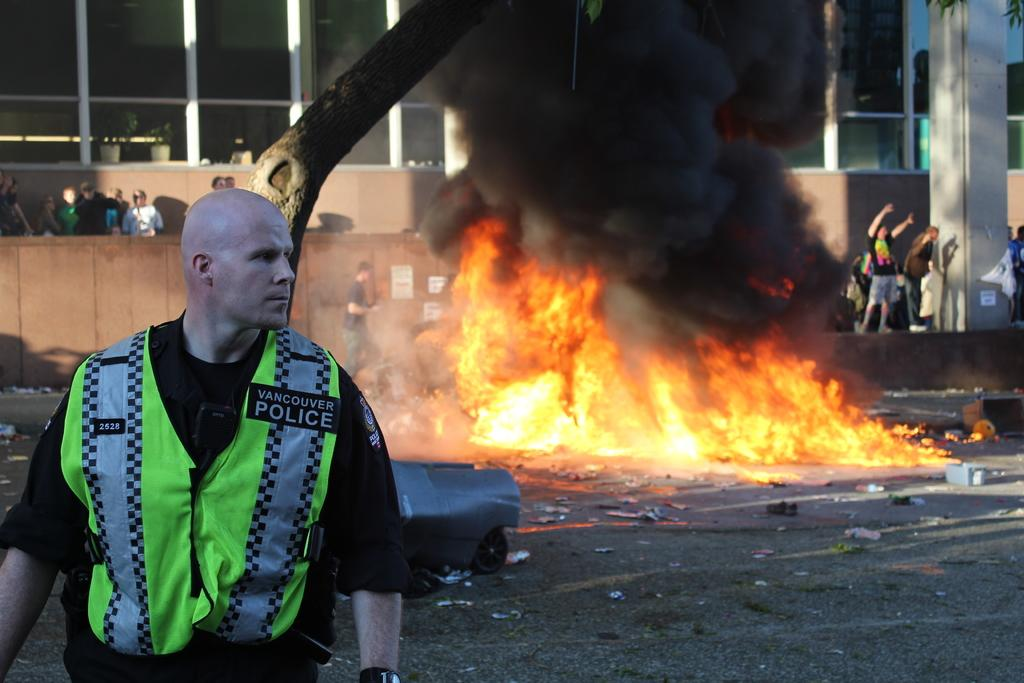Where is the person located in the image? The person is standing in the bottom left corner of the image. What is happening behind the person? There is fire behind the person. Are there any other people in the image? Yes, there are people standing behind the fire. What can be seen at the top of the image? There is a building visible at the top of the image. How many goldfish are swimming in the water near the person in the image? There are no goldfish present in the image. What is the size of the pear that the person is holding in the image? There is no pear present in the image. 